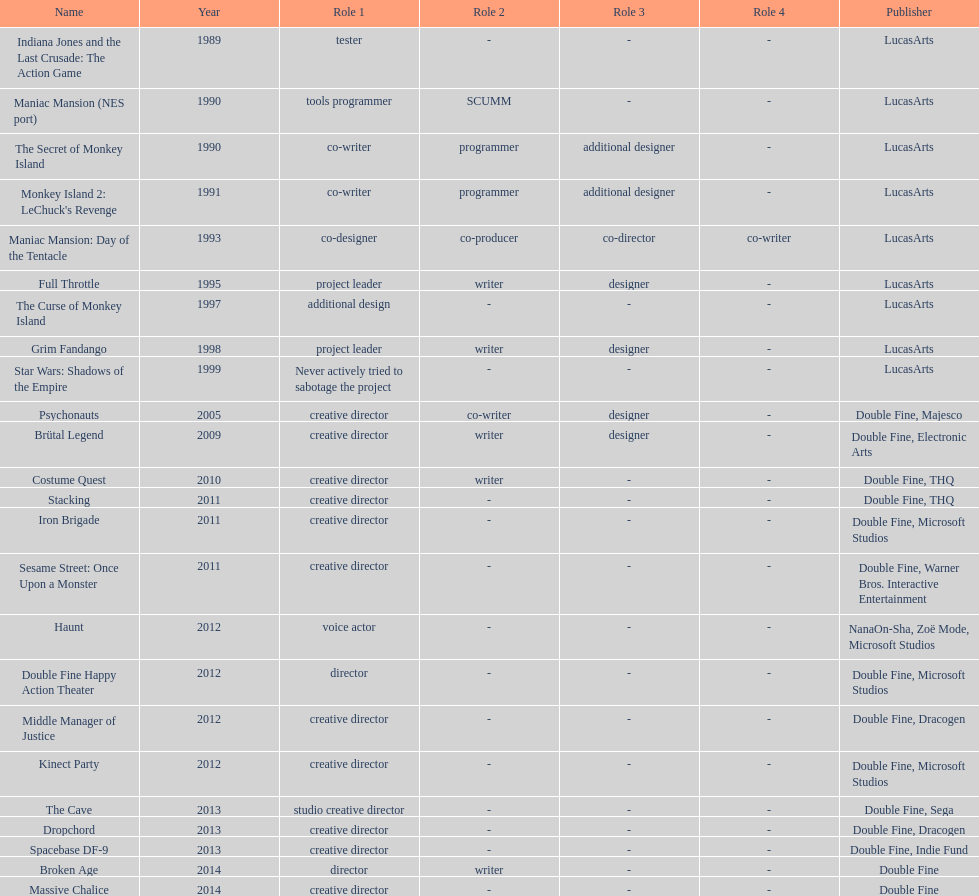How many games were credited with a creative director? 11. 